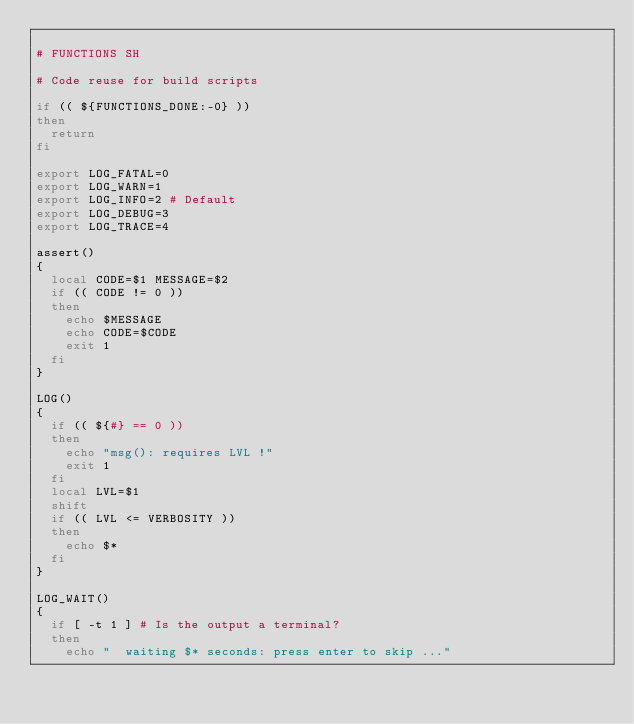<code> <loc_0><loc_0><loc_500><loc_500><_Bash_>
# FUNCTIONS SH

# Code reuse for build scripts

if (( ${FUNCTIONS_DONE:-0} ))
then
  return
fi

export LOG_FATAL=0
export LOG_WARN=1
export LOG_INFO=2 # Default
export LOG_DEBUG=3
export LOG_TRACE=4

assert()
{
  local CODE=$1 MESSAGE=$2
  if (( CODE != 0 ))
  then
    echo $MESSAGE
    echo CODE=$CODE
    exit 1
  fi
}

LOG()
{
  if (( ${#} == 0 ))
  then
    echo "msg(): requires LVL !"
    exit 1
  fi
  local LVL=$1
  shift
  if (( LVL <= VERBOSITY ))
  then
    echo $*
  fi
}

LOG_WAIT()
{
  if [ -t 1 ] # Is the output a terminal?
  then
    echo "  waiting $* seconds: press enter to skip ..."</code> 